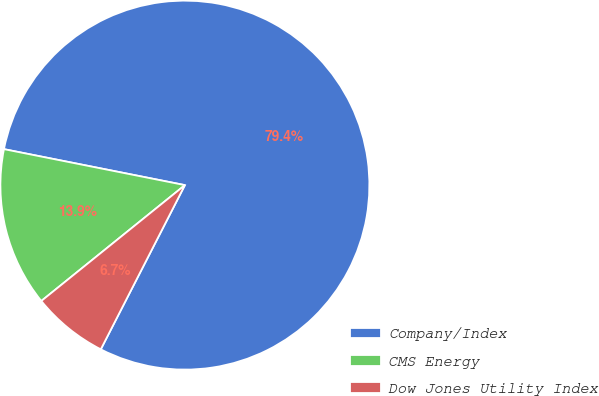Convert chart to OTSL. <chart><loc_0><loc_0><loc_500><loc_500><pie_chart><fcel>Company/Index<fcel>CMS Energy<fcel>Dow Jones Utility Index<nl><fcel>79.41%<fcel>13.93%<fcel>6.66%<nl></chart> 